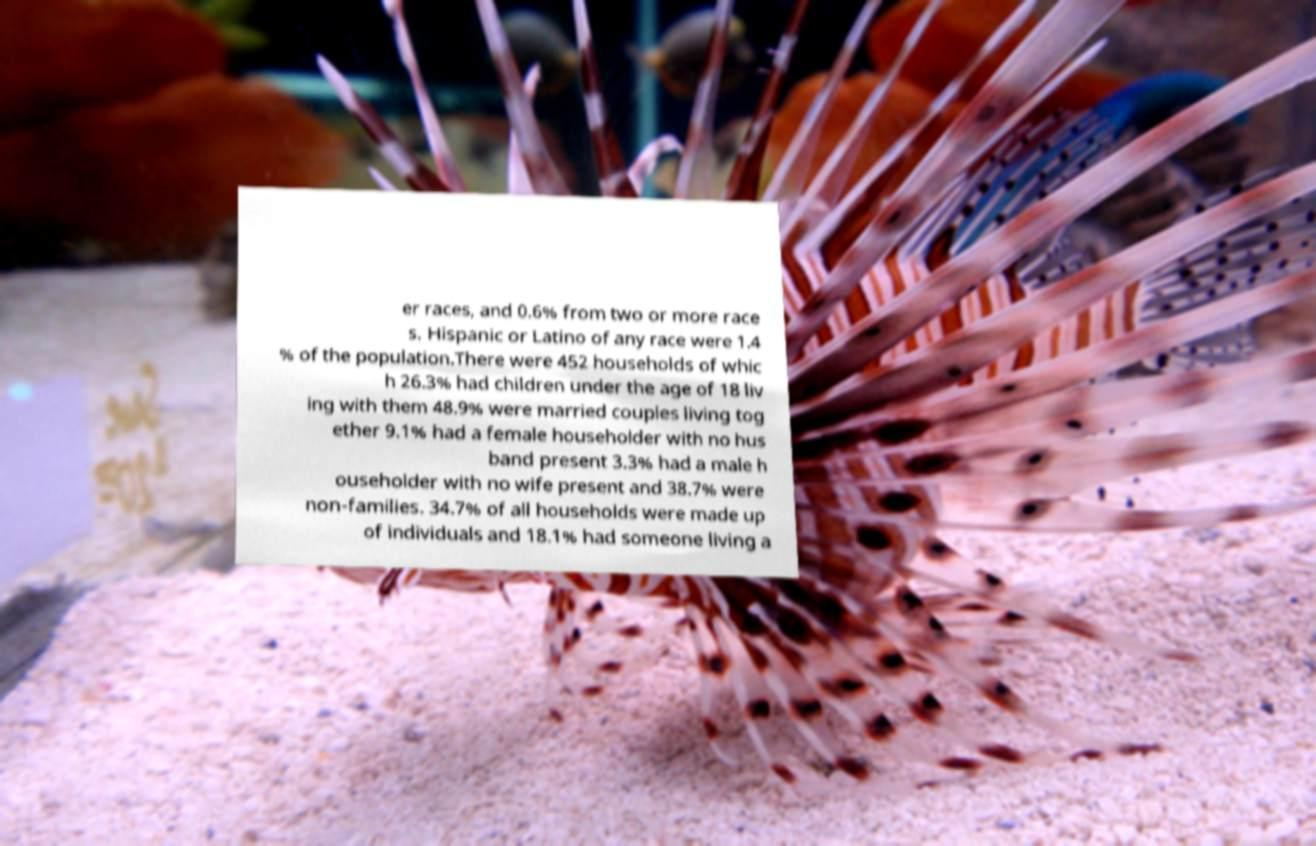What messages or text are displayed in this image? I need them in a readable, typed format. er races, and 0.6% from two or more race s. Hispanic or Latino of any race were 1.4 % of the population.There were 452 households of whic h 26.3% had children under the age of 18 liv ing with them 48.9% were married couples living tog ether 9.1% had a female householder with no hus band present 3.3% had a male h ouseholder with no wife present and 38.7% were non-families. 34.7% of all households were made up of individuals and 18.1% had someone living a 